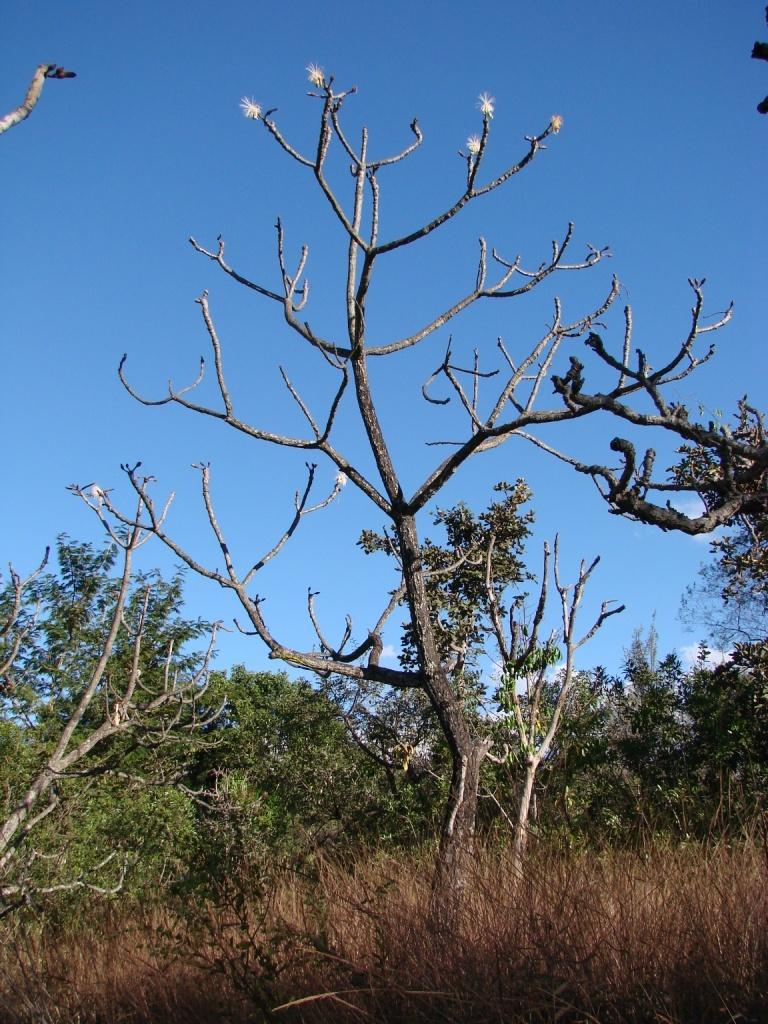What type of vegetation can be seen in the image? There are trees in the image. What part of the natural environment is visible in the image? The sky is visible in the image. What type of marble can be seen in the image? There is no marble present in the image; it features trees and the sky. Is the person in the image taking a selfie? There is no person present in the image, so it is not possible to determine if they are taking a selfie. 